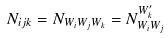<formula> <loc_0><loc_0><loc_500><loc_500>N _ { i j k } = N _ { W _ { i } W _ { j } W _ { k } } = N ^ { W ^ { \prime } _ { k } } _ { W _ { i } W _ { j } }</formula> 